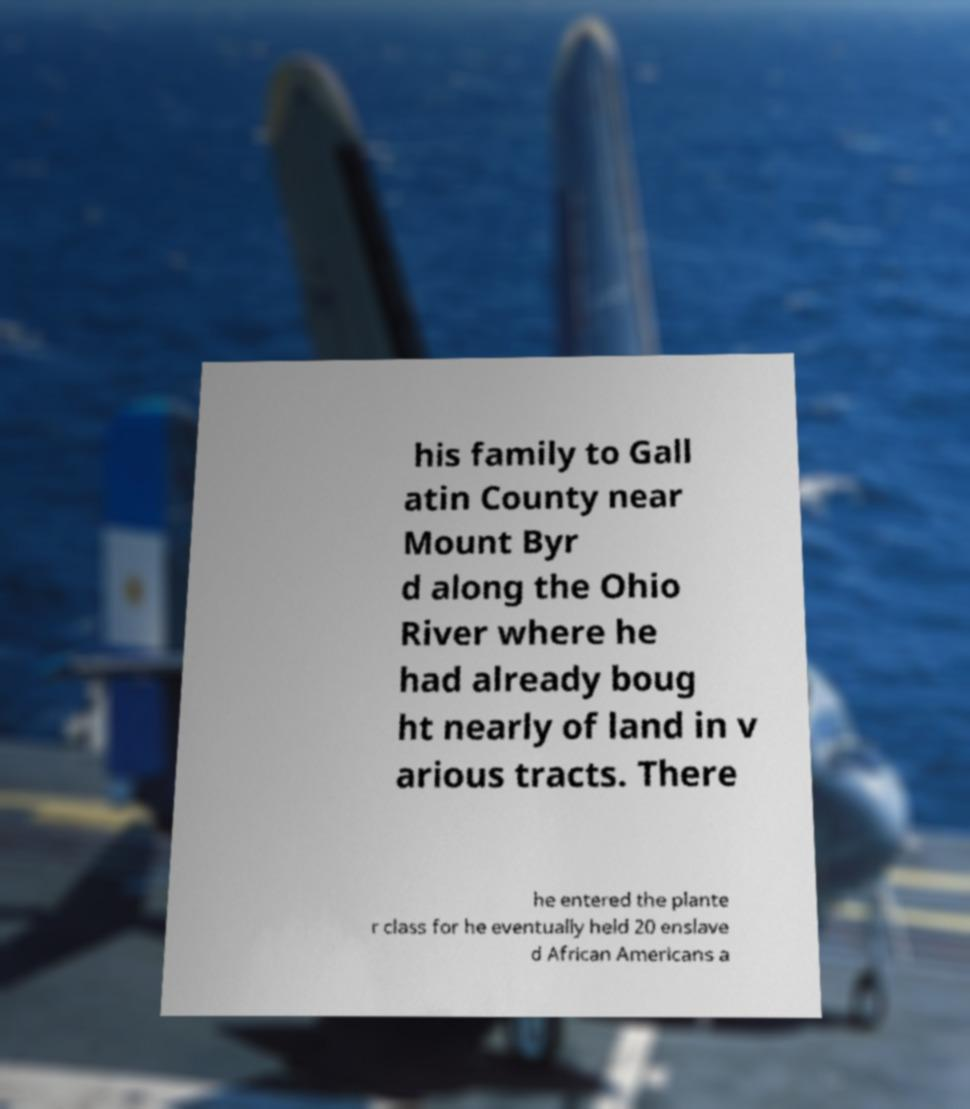Could you extract and type out the text from this image? his family to Gall atin County near Mount Byr d along the Ohio River where he had already boug ht nearly of land in v arious tracts. There he entered the plante r class for he eventually held 20 enslave d African Americans a 